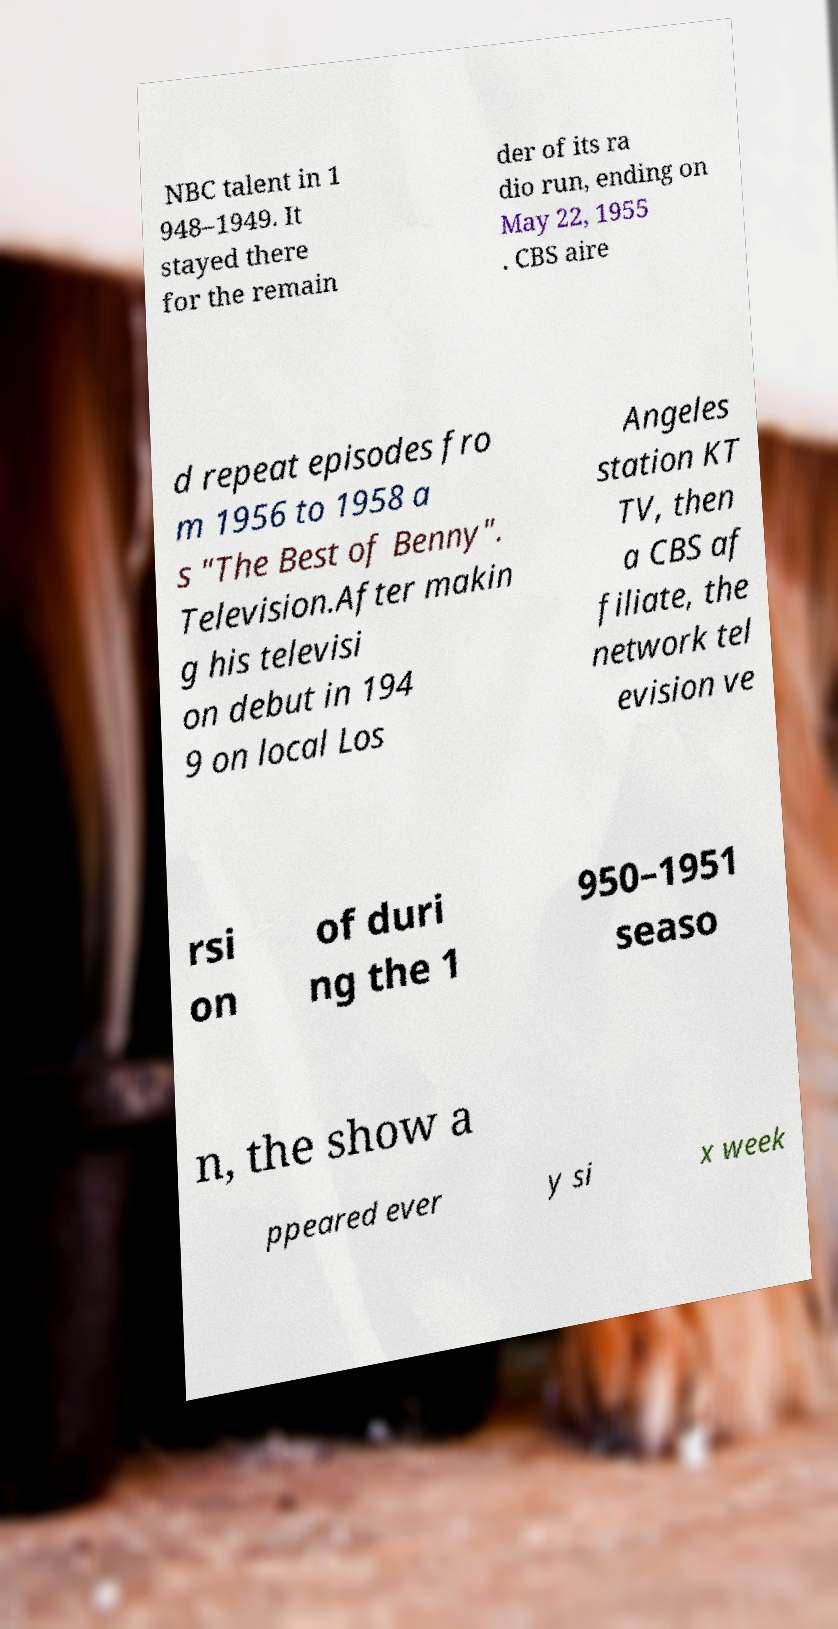Could you extract and type out the text from this image? NBC talent in 1 948–1949. It stayed there for the remain der of its ra dio run, ending on May 22, 1955 . CBS aire d repeat episodes fro m 1956 to 1958 a s "The Best of Benny". Television.After makin g his televisi on debut in 194 9 on local Los Angeles station KT TV, then a CBS af filiate, the network tel evision ve rsi on of duri ng the 1 950–1951 seaso n, the show a ppeared ever y si x week 